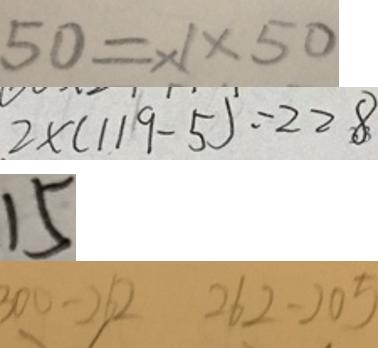<formula> <loc_0><loc_0><loc_500><loc_500>5 0 = \times 1 \times 5 0 
 2 \times ( 1 1 9 - 5 ) = 2 2 8 
 1 5 
 3 0 0 - 2 6 2 2 6 2 - 2 0 5</formula> 